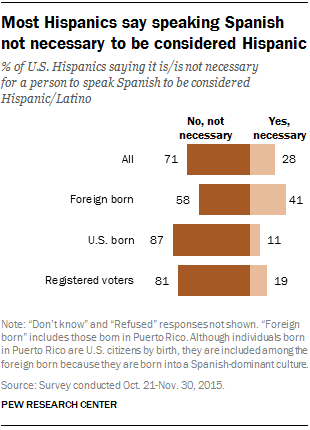Give some essential details in this illustration. It was found that foreign-born Hispanics believed it to be the most necessary to learn English in order to succeed in the United States. According to the study, a significantly greater number of U.S.-born Hispanics, compared to foreign-born ones, felt that it was not necessary to learn English. 